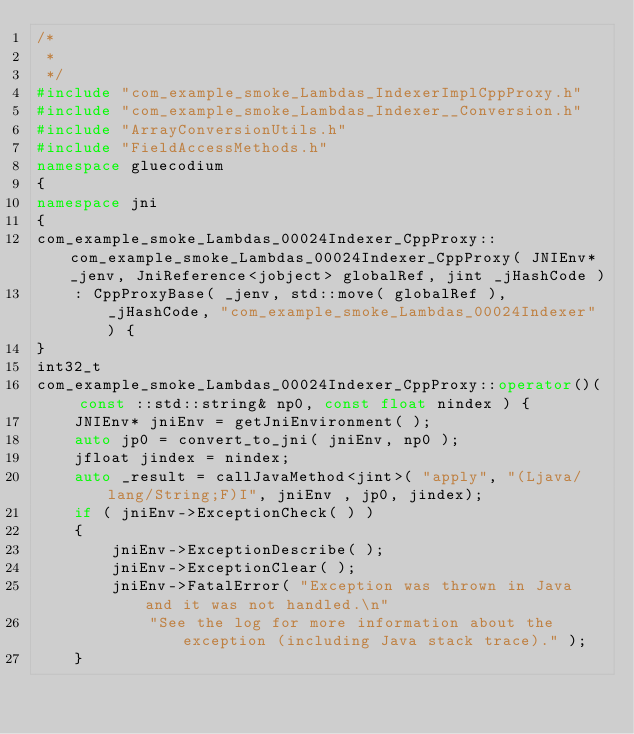Convert code to text. <code><loc_0><loc_0><loc_500><loc_500><_C++_>/*
 *
 */
#include "com_example_smoke_Lambdas_IndexerImplCppProxy.h"
#include "com_example_smoke_Lambdas_Indexer__Conversion.h"
#include "ArrayConversionUtils.h"
#include "FieldAccessMethods.h"
namespace gluecodium
{
namespace jni
{
com_example_smoke_Lambdas_00024Indexer_CppProxy::com_example_smoke_Lambdas_00024Indexer_CppProxy( JNIEnv* _jenv, JniReference<jobject> globalRef, jint _jHashCode )
    : CppProxyBase( _jenv, std::move( globalRef ), _jHashCode, "com_example_smoke_Lambdas_00024Indexer" ) {
}
int32_t
com_example_smoke_Lambdas_00024Indexer_CppProxy::operator()( const ::std::string& np0, const float nindex ) {
    JNIEnv* jniEnv = getJniEnvironment( );
    auto jp0 = convert_to_jni( jniEnv, np0 );
    jfloat jindex = nindex;
    auto _result = callJavaMethod<jint>( "apply", "(Ljava/lang/String;F)I", jniEnv , jp0, jindex);
    if ( jniEnv->ExceptionCheck( ) )
    {
        jniEnv->ExceptionDescribe( );
        jniEnv->ExceptionClear( );
        jniEnv->FatalError( "Exception was thrown in Java and it was not handled.\n"
            "See the log for more information about the exception (including Java stack trace)." );
    }</code> 